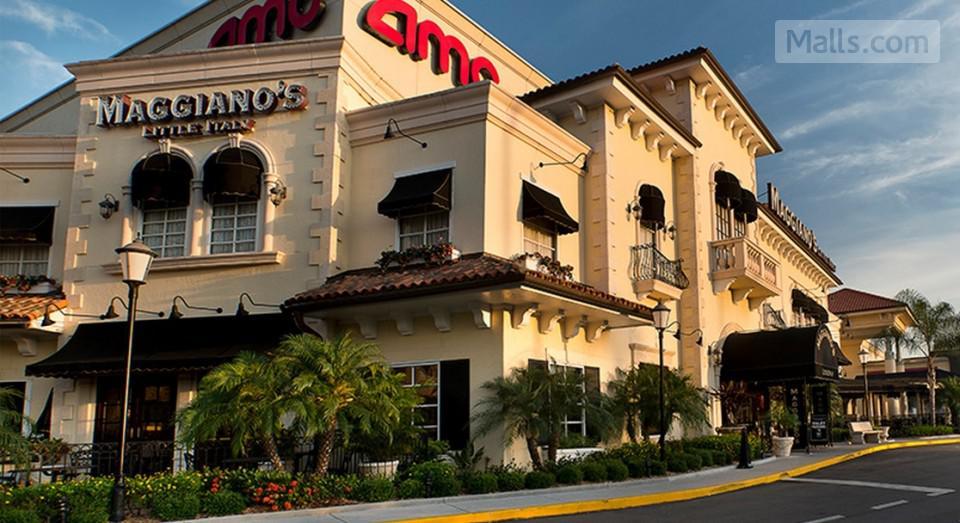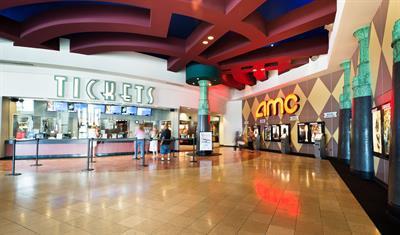The first image is the image on the left, the second image is the image on the right. For the images displayed, is the sentence "An unoccupied table sits near a restaurant in one of the images." factually correct? Answer yes or no. No. The first image is the image on the left, the second image is the image on the right. For the images displayed, is the sentence "The lights in the image on the left are hanging above the counter." factually correct? Answer yes or no. No. 